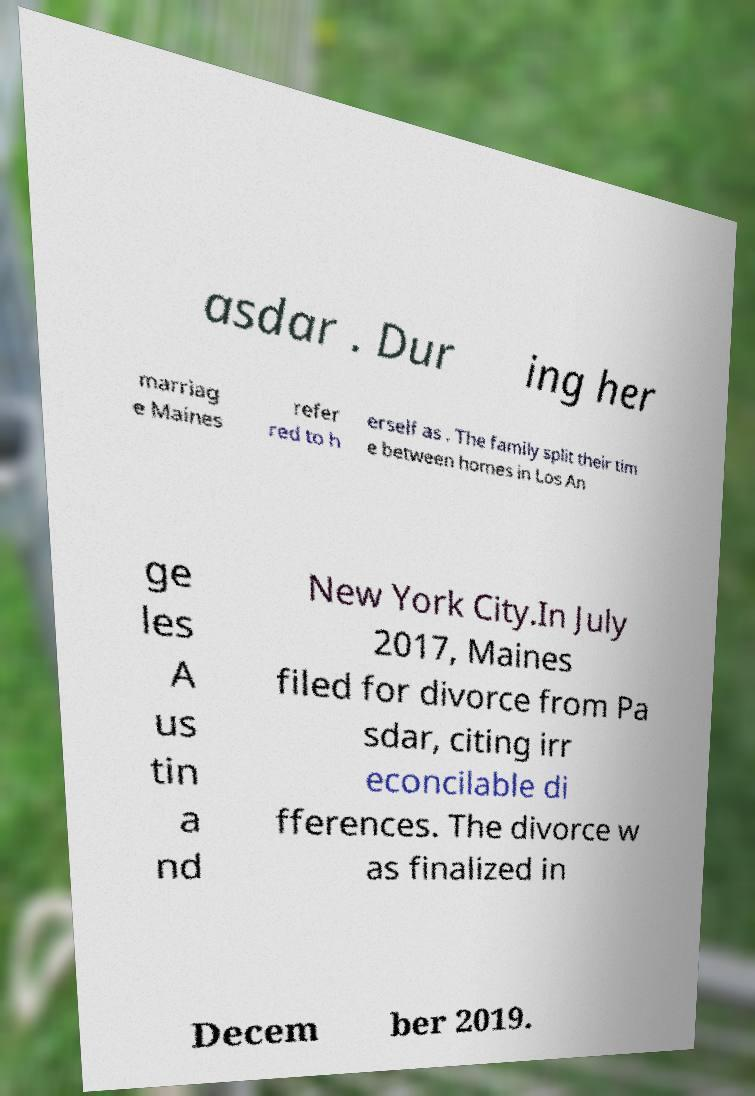For documentation purposes, I need the text within this image transcribed. Could you provide that? asdar . Dur ing her marriag e Maines refer red to h erself as . The family split their tim e between homes in Los An ge les A us tin a nd New York City.In July 2017, Maines filed for divorce from Pa sdar, citing irr econcilable di fferences. The divorce w as finalized in Decem ber 2019. 